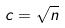<formula> <loc_0><loc_0><loc_500><loc_500>c = \sqrt { n }</formula> 